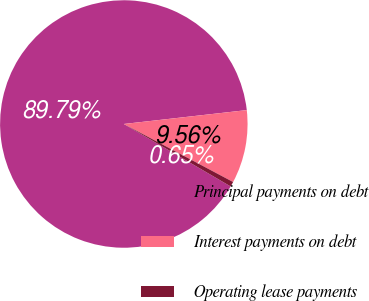<chart> <loc_0><loc_0><loc_500><loc_500><pie_chart><fcel>Principal payments on debt<fcel>Interest payments on debt<fcel>Operating lease payments<nl><fcel>89.79%<fcel>9.56%<fcel>0.65%<nl></chart> 